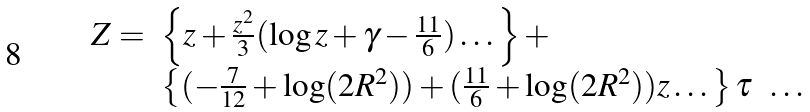<formula> <loc_0><loc_0><loc_500><loc_500>\begin{array} { l l l } Z = & \left \{ z + \frac { z ^ { 2 } } { 3 } ( \log z + \gamma - \frac { 1 1 } { 6 } ) \dots \right \} + & \\ & \left \{ ( - \frac { 7 } { 1 2 } + \log ( 2 R ^ { 2 } ) ) + ( \frac { 1 1 } { 6 } + \log ( 2 R ^ { 2 } ) ) z \dots \right \} \tau & \dots \end{array}</formula> 